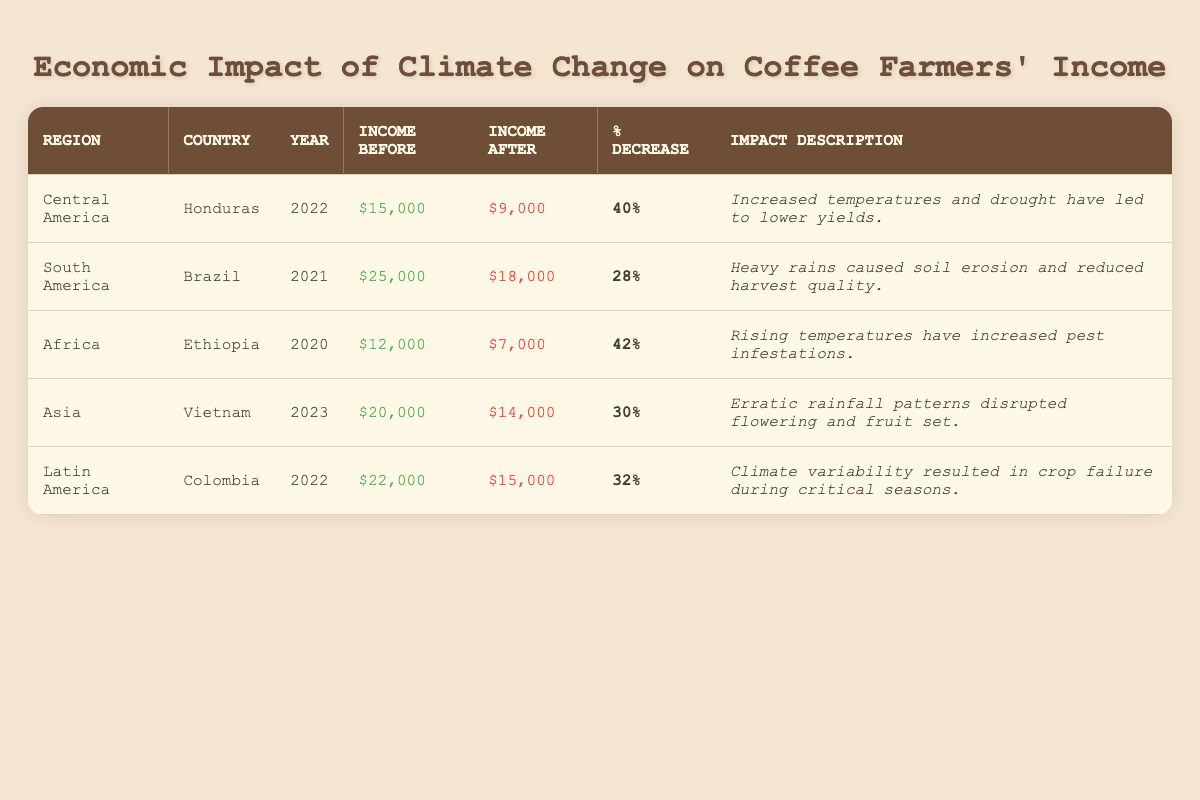What is the average income of coffee farmers in Honduras before climate change? The table shows that the average income for coffee farmers in Honduras before climate change was $15,000.
Answer: $15,000 Which country experienced the highest percentage decrease in income due to climate change? According to the table, Ethiopia had a 42% decrease in income, which is the highest among the listed countries.
Answer: Ethiopia What was the average income of coffee farmers in Brazil after climate change? The table indicates that the average income for coffee farmers in Brazil after climate change was $18,000.
Answer: $18,000 How much did the average income of coffee farmers in Colombia decrease after climate change? The average income for coffee farmers in Colombia decreased from $22,000 to $15,000. Therefore, the decrease is $22,000 - $15,000 = $7,000.
Answer: $7,000 What is the total average income before climate change for all regions listed? To find the total, sum the averages: $15,000 (Honduras) + $25,000 (Brazil) + $12,000 (Ethiopia) + $20,000 (Vietnam) + $22,000 (Colombia) = $94,000.
Answer: $94,000 In which region did coffee farmers experience a 30% income decrease in 2023? The table shows that coffee farmers in Asia, specifically Vietnam, experienced a 30% decrease in income in 2023.
Answer: Asia (Vietnam) How does the average income after climate change for farmers in Ethiopia compare to those in Colombia? The average income after climate change for Ethiopian farmers is $7,000, while for Colombian farmers it is $15,000. Therefore, Ethiopian farmers had a lower average income than Colombian farmers.
Answer: Lower Which region had the least impact on farmer's income based on percentage decrease? The table indicates that Brazil had a 28% decrease, which is the smallest percentage decrease in income among the regions listed.
Answer: South America (Brazil) If we consider both Honduras and Colombia, what is the average income decrease between the two countries? First, determine the decreases: Honduras: 40%, Colombia: 32%. Then, average them: (40 + 32)/2 = 36%.
Answer: 36% Is the average income after climate change for coffee farmers in Vietnam higher than for those in Ethiopia? Yes, Vietnamese farmers have an average income of $14,000 after climate change, while Ethiopian farmers have $7,000, meaning Vietnamese farmers have a higher income.
Answer: Yes What total percentage decrease did farmers in Central America and Africa experience? Calculate the total decrease by adding: Central America (Honduras) 40% + Africa (Ethiopia) 42% = 82%.
Answer: 82% 